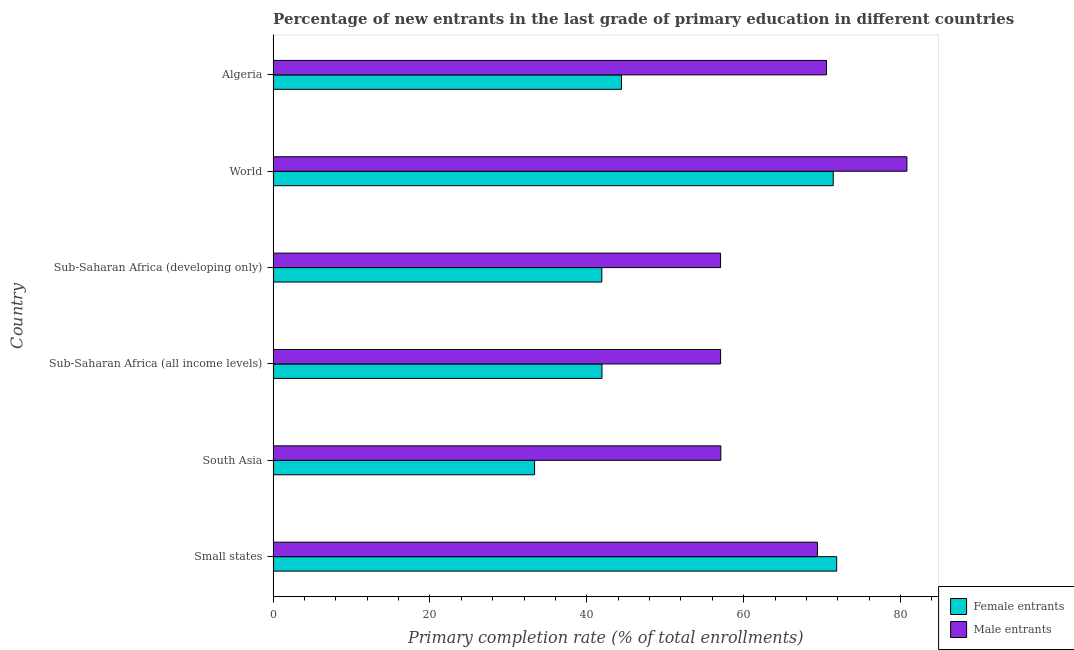How many different coloured bars are there?
Offer a very short reply. 2. How many groups of bars are there?
Make the answer very short. 6. Are the number of bars per tick equal to the number of legend labels?
Provide a short and direct response. Yes. How many bars are there on the 4th tick from the top?
Provide a short and direct response. 2. How many bars are there on the 2nd tick from the bottom?
Your response must be concise. 2. What is the label of the 1st group of bars from the top?
Give a very brief answer. Algeria. In how many cases, is the number of bars for a given country not equal to the number of legend labels?
Your response must be concise. 0. What is the primary completion rate of female entrants in Sub-Saharan Africa (developing only)?
Provide a short and direct response. 41.92. Across all countries, what is the maximum primary completion rate of female entrants?
Your answer should be very brief. 71.86. Across all countries, what is the minimum primary completion rate of male entrants?
Keep it short and to the point. 57.06. In which country was the primary completion rate of female entrants maximum?
Your response must be concise. Small states. In which country was the primary completion rate of male entrants minimum?
Your response must be concise. Sub-Saharan Africa (developing only). What is the total primary completion rate of male entrants in the graph?
Your response must be concise. 392. What is the difference between the primary completion rate of female entrants in Algeria and that in Sub-Saharan Africa (all income levels)?
Provide a short and direct response. 2.48. What is the difference between the primary completion rate of female entrants in World and the primary completion rate of male entrants in Sub-Saharan Africa (developing only)?
Your answer should be compact. 14.37. What is the average primary completion rate of female entrants per country?
Offer a very short reply. 50.82. What is the difference between the primary completion rate of female entrants and primary completion rate of male entrants in Small states?
Offer a terse response. 2.46. Is the primary completion rate of female entrants in Sub-Saharan Africa (all income levels) less than that in World?
Ensure brevity in your answer.  Yes. What is the difference between the highest and the second highest primary completion rate of male entrants?
Provide a succinct answer. 10.26. What is the difference between the highest and the lowest primary completion rate of male entrants?
Offer a very short reply. 23.76. Is the sum of the primary completion rate of female entrants in Sub-Saharan Africa (all income levels) and Sub-Saharan Africa (developing only) greater than the maximum primary completion rate of male entrants across all countries?
Provide a short and direct response. Yes. What does the 1st bar from the top in Algeria represents?
Your answer should be very brief. Male entrants. What does the 2nd bar from the bottom in Sub-Saharan Africa (developing only) represents?
Your response must be concise. Male entrants. How many bars are there?
Your answer should be very brief. 12. What is the difference between two consecutive major ticks on the X-axis?
Your response must be concise. 20. Does the graph contain grids?
Offer a very short reply. No. Where does the legend appear in the graph?
Keep it short and to the point. Bottom right. How are the legend labels stacked?
Ensure brevity in your answer.  Vertical. What is the title of the graph?
Your answer should be compact. Percentage of new entrants in the last grade of primary education in different countries. What is the label or title of the X-axis?
Offer a terse response. Primary completion rate (% of total enrollments). What is the Primary completion rate (% of total enrollments) in Female entrants in Small states?
Provide a succinct answer. 71.86. What is the Primary completion rate (% of total enrollments) in Male entrants in Small states?
Keep it short and to the point. 69.41. What is the Primary completion rate (% of total enrollments) of Female entrants in South Asia?
Your answer should be very brief. 33.34. What is the Primary completion rate (% of total enrollments) of Male entrants in South Asia?
Give a very brief answer. 57.09. What is the Primary completion rate (% of total enrollments) of Female entrants in Sub-Saharan Africa (all income levels)?
Your answer should be very brief. 41.93. What is the Primary completion rate (% of total enrollments) in Male entrants in Sub-Saharan Africa (all income levels)?
Keep it short and to the point. 57.06. What is the Primary completion rate (% of total enrollments) of Female entrants in Sub-Saharan Africa (developing only)?
Provide a short and direct response. 41.92. What is the Primary completion rate (% of total enrollments) in Male entrants in Sub-Saharan Africa (developing only)?
Your response must be concise. 57.06. What is the Primary completion rate (% of total enrollments) in Female entrants in World?
Make the answer very short. 71.42. What is the Primary completion rate (% of total enrollments) of Male entrants in World?
Provide a succinct answer. 80.82. What is the Primary completion rate (% of total enrollments) in Female entrants in Algeria?
Provide a succinct answer. 44.42. What is the Primary completion rate (% of total enrollments) in Male entrants in Algeria?
Your answer should be compact. 70.56. Across all countries, what is the maximum Primary completion rate (% of total enrollments) of Female entrants?
Make the answer very short. 71.86. Across all countries, what is the maximum Primary completion rate (% of total enrollments) in Male entrants?
Your response must be concise. 80.82. Across all countries, what is the minimum Primary completion rate (% of total enrollments) of Female entrants?
Offer a very short reply. 33.34. Across all countries, what is the minimum Primary completion rate (% of total enrollments) in Male entrants?
Keep it short and to the point. 57.06. What is the total Primary completion rate (% of total enrollments) in Female entrants in the graph?
Offer a terse response. 304.9. What is the total Primary completion rate (% of total enrollments) of Male entrants in the graph?
Your answer should be compact. 392. What is the difference between the Primary completion rate (% of total enrollments) in Female entrants in Small states and that in South Asia?
Make the answer very short. 38.52. What is the difference between the Primary completion rate (% of total enrollments) in Male entrants in Small states and that in South Asia?
Make the answer very short. 12.32. What is the difference between the Primary completion rate (% of total enrollments) in Female entrants in Small states and that in Sub-Saharan Africa (all income levels)?
Your answer should be compact. 29.93. What is the difference between the Primary completion rate (% of total enrollments) in Male entrants in Small states and that in Sub-Saharan Africa (all income levels)?
Provide a short and direct response. 12.34. What is the difference between the Primary completion rate (% of total enrollments) of Female entrants in Small states and that in Sub-Saharan Africa (developing only)?
Your response must be concise. 29.95. What is the difference between the Primary completion rate (% of total enrollments) of Male entrants in Small states and that in Sub-Saharan Africa (developing only)?
Your answer should be compact. 12.35. What is the difference between the Primary completion rate (% of total enrollments) in Female entrants in Small states and that in World?
Provide a succinct answer. 0.44. What is the difference between the Primary completion rate (% of total enrollments) of Male entrants in Small states and that in World?
Your response must be concise. -11.41. What is the difference between the Primary completion rate (% of total enrollments) in Female entrants in Small states and that in Algeria?
Offer a terse response. 27.44. What is the difference between the Primary completion rate (% of total enrollments) in Male entrants in Small states and that in Algeria?
Offer a very short reply. -1.16. What is the difference between the Primary completion rate (% of total enrollments) of Female entrants in South Asia and that in Sub-Saharan Africa (all income levels)?
Offer a terse response. -8.59. What is the difference between the Primary completion rate (% of total enrollments) in Male entrants in South Asia and that in Sub-Saharan Africa (all income levels)?
Your answer should be very brief. 0.03. What is the difference between the Primary completion rate (% of total enrollments) of Female entrants in South Asia and that in Sub-Saharan Africa (developing only)?
Give a very brief answer. -8.57. What is the difference between the Primary completion rate (% of total enrollments) of Male entrants in South Asia and that in Sub-Saharan Africa (developing only)?
Give a very brief answer. 0.04. What is the difference between the Primary completion rate (% of total enrollments) in Female entrants in South Asia and that in World?
Your answer should be compact. -38.08. What is the difference between the Primary completion rate (% of total enrollments) in Male entrants in South Asia and that in World?
Your answer should be very brief. -23.73. What is the difference between the Primary completion rate (% of total enrollments) in Female entrants in South Asia and that in Algeria?
Your answer should be compact. -11.08. What is the difference between the Primary completion rate (% of total enrollments) in Male entrants in South Asia and that in Algeria?
Keep it short and to the point. -13.47. What is the difference between the Primary completion rate (% of total enrollments) of Female entrants in Sub-Saharan Africa (all income levels) and that in Sub-Saharan Africa (developing only)?
Your answer should be very brief. 0.02. What is the difference between the Primary completion rate (% of total enrollments) in Male entrants in Sub-Saharan Africa (all income levels) and that in Sub-Saharan Africa (developing only)?
Ensure brevity in your answer.  0.01. What is the difference between the Primary completion rate (% of total enrollments) of Female entrants in Sub-Saharan Africa (all income levels) and that in World?
Make the answer very short. -29.49. What is the difference between the Primary completion rate (% of total enrollments) in Male entrants in Sub-Saharan Africa (all income levels) and that in World?
Offer a very short reply. -23.75. What is the difference between the Primary completion rate (% of total enrollments) in Female entrants in Sub-Saharan Africa (all income levels) and that in Algeria?
Your answer should be very brief. -2.48. What is the difference between the Primary completion rate (% of total enrollments) of Male entrants in Sub-Saharan Africa (all income levels) and that in Algeria?
Ensure brevity in your answer.  -13.5. What is the difference between the Primary completion rate (% of total enrollments) in Female entrants in Sub-Saharan Africa (developing only) and that in World?
Provide a succinct answer. -29.51. What is the difference between the Primary completion rate (% of total enrollments) of Male entrants in Sub-Saharan Africa (developing only) and that in World?
Give a very brief answer. -23.76. What is the difference between the Primary completion rate (% of total enrollments) in Female entrants in Sub-Saharan Africa (developing only) and that in Algeria?
Your response must be concise. -2.5. What is the difference between the Primary completion rate (% of total enrollments) in Male entrants in Sub-Saharan Africa (developing only) and that in Algeria?
Make the answer very short. -13.51. What is the difference between the Primary completion rate (% of total enrollments) of Female entrants in World and that in Algeria?
Give a very brief answer. 27. What is the difference between the Primary completion rate (% of total enrollments) of Male entrants in World and that in Algeria?
Your response must be concise. 10.25. What is the difference between the Primary completion rate (% of total enrollments) of Female entrants in Small states and the Primary completion rate (% of total enrollments) of Male entrants in South Asia?
Your response must be concise. 14.77. What is the difference between the Primary completion rate (% of total enrollments) in Female entrants in Small states and the Primary completion rate (% of total enrollments) in Male entrants in Sub-Saharan Africa (all income levels)?
Offer a very short reply. 14.8. What is the difference between the Primary completion rate (% of total enrollments) in Female entrants in Small states and the Primary completion rate (% of total enrollments) in Male entrants in Sub-Saharan Africa (developing only)?
Keep it short and to the point. 14.81. What is the difference between the Primary completion rate (% of total enrollments) of Female entrants in Small states and the Primary completion rate (% of total enrollments) of Male entrants in World?
Ensure brevity in your answer.  -8.95. What is the difference between the Primary completion rate (% of total enrollments) in Female entrants in Small states and the Primary completion rate (% of total enrollments) in Male entrants in Algeria?
Give a very brief answer. 1.3. What is the difference between the Primary completion rate (% of total enrollments) in Female entrants in South Asia and the Primary completion rate (% of total enrollments) in Male entrants in Sub-Saharan Africa (all income levels)?
Ensure brevity in your answer.  -23.72. What is the difference between the Primary completion rate (% of total enrollments) in Female entrants in South Asia and the Primary completion rate (% of total enrollments) in Male entrants in Sub-Saharan Africa (developing only)?
Your answer should be compact. -23.71. What is the difference between the Primary completion rate (% of total enrollments) in Female entrants in South Asia and the Primary completion rate (% of total enrollments) in Male entrants in World?
Provide a succinct answer. -47.48. What is the difference between the Primary completion rate (% of total enrollments) of Female entrants in South Asia and the Primary completion rate (% of total enrollments) of Male entrants in Algeria?
Keep it short and to the point. -37.22. What is the difference between the Primary completion rate (% of total enrollments) in Female entrants in Sub-Saharan Africa (all income levels) and the Primary completion rate (% of total enrollments) in Male entrants in Sub-Saharan Africa (developing only)?
Offer a terse response. -15.12. What is the difference between the Primary completion rate (% of total enrollments) of Female entrants in Sub-Saharan Africa (all income levels) and the Primary completion rate (% of total enrollments) of Male entrants in World?
Make the answer very short. -38.88. What is the difference between the Primary completion rate (% of total enrollments) of Female entrants in Sub-Saharan Africa (all income levels) and the Primary completion rate (% of total enrollments) of Male entrants in Algeria?
Offer a very short reply. -28.63. What is the difference between the Primary completion rate (% of total enrollments) in Female entrants in Sub-Saharan Africa (developing only) and the Primary completion rate (% of total enrollments) in Male entrants in World?
Give a very brief answer. -38.9. What is the difference between the Primary completion rate (% of total enrollments) in Female entrants in Sub-Saharan Africa (developing only) and the Primary completion rate (% of total enrollments) in Male entrants in Algeria?
Give a very brief answer. -28.65. What is the difference between the Primary completion rate (% of total enrollments) in Female entrants in World and the Primary completion rate (% of total enrollments) in Male entrants in Algeria?
Your answer should be very brief. 0.86. What is the average Primary completion rate (% of total enrollments) of Female entrants per country?
Provide a short and direct response. 50.82. What is the average Primary completion rate (% of total enrollments) of Male entrants per country?
Provide a short and direct response. 65.33. What is the difference between the Primary completion rate (% of total enrollments) in Female entrants and Primary completion rate (% of total enrollments) in Male entrants in Small states?
Your answer should be very brief. 2.46. What is the difference between the Primary completion rate (% of total enrollments) in Female entrants and Primary completion rate (% of total enrollments) in Male entrants in South Asia?
Your response must be concise. -23.75. What is the difference between the Primary completion rate (% of total enrollments) in Female entrants and Primary completion rate (% of total enrollments) in Male entrants in Sub-Saharan Africa (all income levels)?
Ensure brevity in your answer.  -15.13. What is the difference between the Primary completion rate (% of total enrollments) in Female entrants and Primary completion rate (% of total enrollments) in Male entrants in Sub-Saharan Africa (developing only)?
Give a very brief answer. -15.14. What is the difference between the Primary completion rate (% of total enrollments) in Female entrants and Primary completion rate (% of total enrollments) in Male entrants in World?
Keep it short and to the point. -9.39. What is the difference between the Primary completion rate (% of total enrollments) in Female entrants and Primary completion rate (% of total enrollments) in Male entrants in Algeria?
Your response must be concise. -26.14. What is the ratio of the Primary completion rate (% of total enrollments) of Female entrants in Small states to that in South Asia?
Provide a short and direct response. 2.16. What is the ratio of the Primary completion rate (% of total enrollments) of Male entrants in Small states to that in South Asia?
Provide a succinct answer. 1.22. What is the ratio of the Primary completion rate (% of total enrollments) of Female entrants in Small states to that in Sub-Saharan Africa (all income levels)?
Ensure brevity in your answer.  1.71. What is the ratio of the Primary completion rate (% of total enrollments) in Male entrants in Small states to that in Sub-Saharan Africa (all income levels)?
Make the answer very short. 1.22. What is the ratio of the Primary completion rate (% of total enrollments) in Female entrants in Small states to that in Sub-Saharan Africa (developing only)?
Offer a terse response. 1.71. What is the ratio of the Primary completion rate (% of total enrollments) of Male entrants in Small states to that in Sub-Saharan Africa (developing only)?
Provide a short and direct response. 1.22. What is the ratio of the Primary completion rate (% of total enrollments) of Male entrants in Small states to that in World?
Offer a very short reply. 0.86. What is the ratio of the Primary completion rate (% of total enrollments) of Female entrants in Small states to that in Algeria?
Make the answer very short. 1.62. What is the ratio of the Primary completion rate (% of total enrollments) of Male entrants in Small states to that in Algeria?
Offer a terse response. 0.98. What is the ratio of the Primary completion rate (% of total enrollments) of Female entrants in South Asia to that in Sub-Saharan Africa (all income levels)?
Your answer should be compact. 0.8. What is the ratio of the Primary completion rate (% of total enrollments) in Male entrants in South Asia to that in Sub-Saharan Africa (all income levels)?
Offer a very short reply. 1. What is the ratio of the Primary completion rate (% of total enrollments) in Female entrants in South Asia to that in Sub-Saharan Africa (developing only)?
Make the answer very short. 0.8. What is the ratio of the Primary completion rate (% of total enrollments) in Female entrants in South Asia to that in World?
Offer a terse response. 0.47. What is the ratio of the Primary completion rate (% of total enrollments) of Male entrants in South Asia to that in World?
Your response must be concise. 0.71. What is the ratio of the Primary completion rate (% of total enrollments) in Female entrants in South Asia to that in Algeria?
Provide a short and direct response. 0.75. What is the ratio of the Primary completion rate (% of total enrollments) in Male entrants in South Asia to that in Algeria?
Give a very brief answer. 0.81. What is the ratio of the Primary completion rate (% of total enrollments) of Female entrants in Sub-Saharan Africa (all income levels) to that in Sub-Saharan Africa (developing only)?
Your answer should be very brief. 1. What is the ratio of the Primary completion rate (% of total enrollments) in Male entrants in Sub-Saharan Africa (all income levels) to that in Sub-Saharan Africa (developing only)?
Ensure brevity in your answer.  1. What is the ratio of the Primary completion rate (% of total enrollments) in Female entrants in Sub-Saharan Africa (all income levels) to that in World?
Ensure brevity in your answer.  0.59. What is the ratio of the Primary completion rate (% of total enrollments) in Male entrants in Sub-Saharan Africa (all income levels) to that in World?
Ensure brevity in your answer.  0.71. What is the ratio of the Primary completion rate (% of total enrollments) in Female entrants in Sub-Saharan Africa (all income levels) to that in Algeria?
Offer a terse response. 0.94. What is the ratio of the Primary completion rate (% of total enrollments) in Male entrants in Sub-Saharan Africa (all income levels) to that in Algeria?
Make the answer very short. 0.81. What is the ratio of the Primary completion rate (% of total enrollments) of Female entrants in Sub-Saharan Africa (developing only) to that in World?
Give a very brief answer. 0.59. What is the ratio of the Primary completion rate (% of total enrollments) of Male entrants in Sub-Saharan Africa (developing only) to that in World?
Your answer should be very brief. 0.71. What is the ratio of the Primary completion rate (% of total enrollments) in Female entrants in Sub-Saharan Africa (developing only) to that in Algeria?
Provide a short and direct response. 0.94. What is the ratio of the Primary completion rate (% of total enrollments) in Male entrants in Sub-Saharan Africa (developing only) to that in Algeria?
Your answer should be very brief. 0.81. What is the ratio of the Primary completion rate (% of total enrollments) of Female entrants in World to that in Algeria?
Keep it short and to the point. 1.61. What is the ratio of the Primary completion rate (% of total enrollments) in Male entrants in World to that in Algeria?
Keep it short and to the point. 1.15. What is the difference between the highest and the second highest Primary completion rate (% of total enrollments) in Female entrants?
Your answer should be very brief. 0.44. What is the difference between the highest and the second highest Primary completion rate (% of total enrollments) of Male entrants?
Your answer should be very brief. 10.25. What is the difference between the highest and the lowest Primary completion rate (% of total enrollments) in Female entrants?
Keep it short and to the point. 38.52. What is the difference between the highest and the lowest Primary completion rate (% of total enrollments) in Male entrants?
Ensure brevity in your answer.  23.76. 